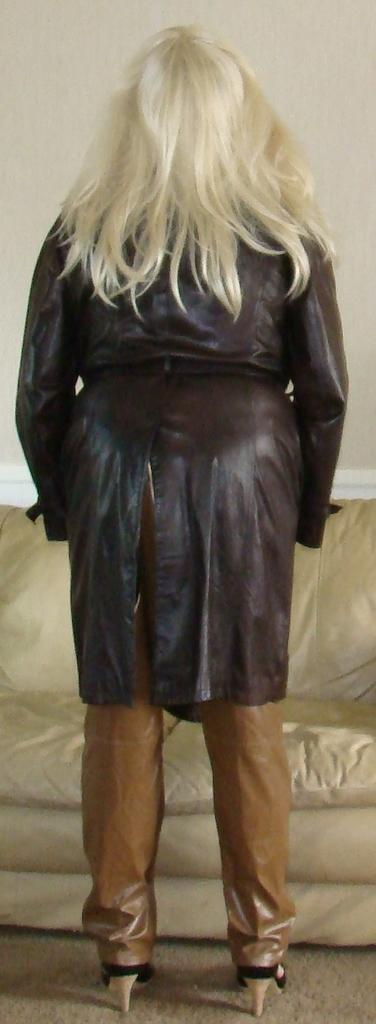Who is present in the image? There is a woman standing in the image. What is the woman standing on? The woman is standing on the floor. What can be seen in the background of the image? There is a sofa and a wall in the background of the image. What type of bait is the woman using to catch fish in the image? There is no indication of fishing or bait in the image; the woman is simply standing on the floor. 